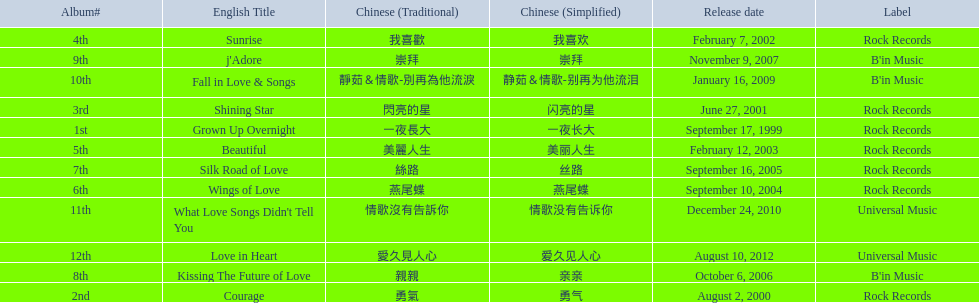Could you parse the entire table as a dict? {'header': ['Album#', 'English Title', 'Chinese (Traditional)', 'Chinese (Simplified)', 'Release date', 'Label'], 'rows': [['4th', 'Sunrise', '我喜歡', '我喜欢', 'February 7, 2002', 'Rock Records'], ['9th', "j'Adore", '崇拜', '崇拜', 'November 9, 2007', "B'in Music"], ['10th', 'Fall in Love & Songs', '靜茹＆情歌-別再為他流淚', '静茹＆情歌-别再为他流泪', 'January 16, 2009', "B'in Music"], ['3rd', 'Shining Star', '閃亮的星', '闪亮的星', 'June 27, 2001', 'Rock Records'], ['1st', 'Grown Up Overnight', '一夜長大', '一夜长大', 'September 17, 1999', 'Rock Records'], ['5th', 'Beautiful', '美麗人生', '美丽人生', 'February 12, 2003', 'Rock Records'], ['7th', 'Silk Road of Love', '絲路', '丝路', 'September 16, 2005', 'Rock Records'], ['6th', 'Wings of Love', '燕尾蝶', '燕尾蝶', 'September 10, 2004', 'Rock Records'], ['11th', "What Love Songs Didn't Tell You", '情歌沒有告訴你', '情歌没有告诉你', 'December 24, 2010', 'Universal Music'], ['12th', 'Love in Heart', '愛久見人心', '爱久见人心', 'August 10, 2012', 'Universal Music'], ['8th', 'Kissing The Future of Love', '親親', '亲亲', 'October 6, 2006', "B'in Music"], ['2nd', 'Courage', '勇氣', '勇气', 'August 2, 2000', 'Rock Records']]} What is the number of songs on rock records? 7. 